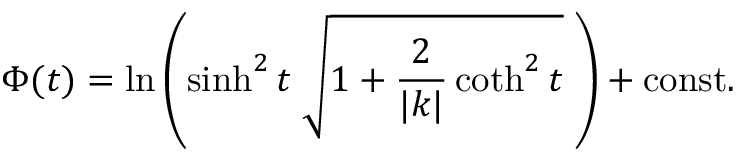<formula> <loc_0><loc_0><loc_500><loc_500>\Phi ( t ) = \ln \left ( \sinh ^ { 2 } t \, \sqrt { 1 + \frac { 2 } { | k | } \coth ^ { 2 } t } \, \right ) + c o n s t .</formula> 